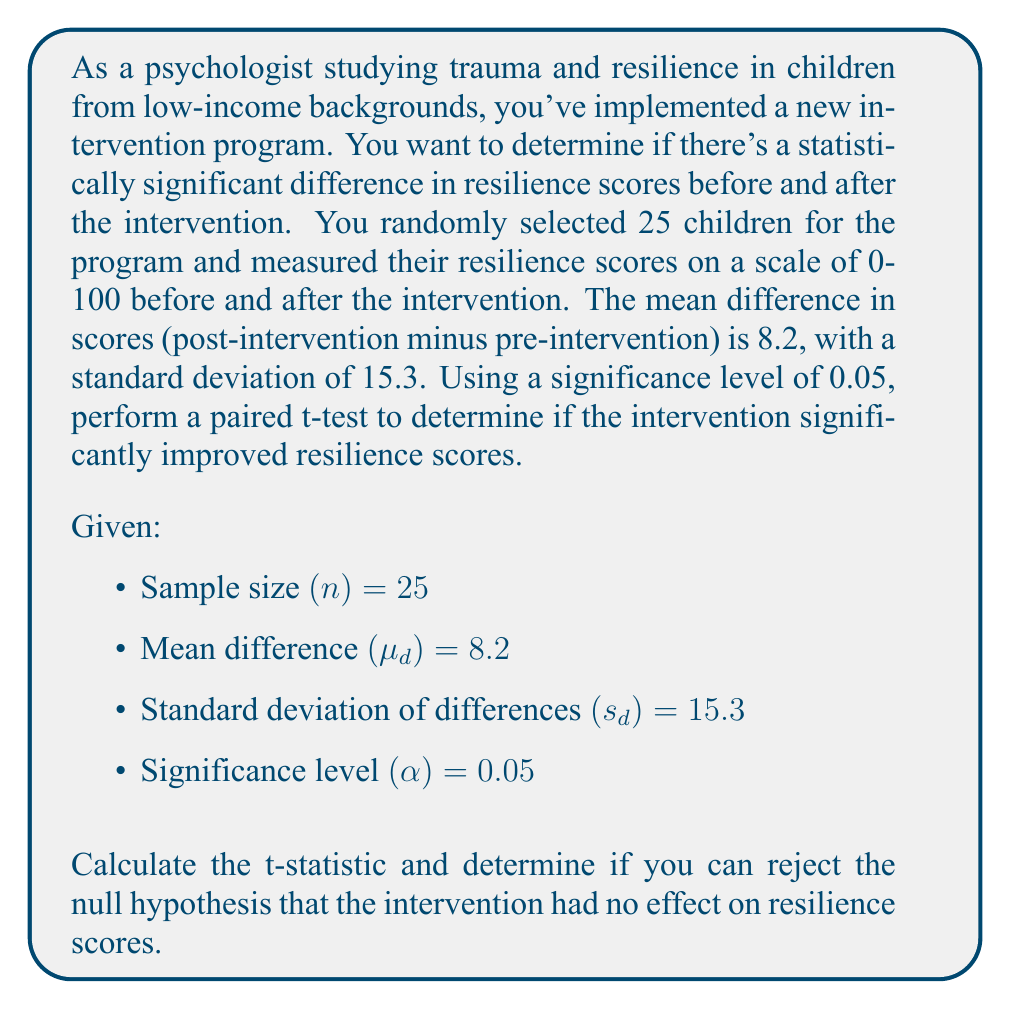Solve this math problem. To determine if there's a statistically significant difference in resilience scores, we'll perform a paired t-test. Here's the step-by-step process:

1. State the hypotheses:
   $H_0: \mu_d = 0$ (null hypothesis: no significant difference)
   $H_a: \mu_d \neq 0$ (alternative hypothesis: significant difference)

2. Calculate the t-statistic using the formula:
   $$t = \frac{\bar{d}}{s_d / \sqrt{n}}$$
   Where $\bar{d}$ is the mean difference, $s_d$ is the standard deviation of differences, and n is the sample size.

3. Plug in the values:
   $$t = \frac{8.2}{15.3 / \sqrt{25}} = \frac{8.2}{15.3 / 5} = \frac{8.2}{3.06} = 2.68$$

4. Determine the critical t-value:
   For a two-tailed test with α = 0.05 and df = n - 1 = 24, the critical t-value is approximately ±2.064.

5. Compare the calculated t-statistic to the critical t-value:
   |2.68| > 2.064, so we reject the null hypothesis.

6. Calculate the p-value:
   Using a t-distribution calculator or table, we find that the p-value for t = 2.68 with 24 degrees of freedom is approximately 0.013.

7. Interpret the results:
   Since p < α (0.013 < 0.05), we reject the null hypothesis and conclude that there is a statistically significant difference in resilience scores before and after the intervention.
Answer: Reject null hypothesis; t(24) = 2.68, p = 0.013 < 0.05 